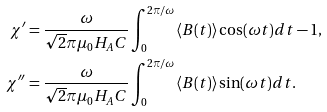Convert formula to latex. <formula><loc_0><loc_0><loc_500><loc_500>\chi ^ { \prime } & = \frac { \omega } { \sqrt { 2 } \pi \mu _ { 0 } H _ { A } C } \int ^ { 2 \pi / \omega } _ { 0 } \langle B ( t ) \rangle \cos ( \omega t ) d t - 1 , \\ \chi ^ { \prime \prime } & = \frac { \omega } { \sqrt { 2 } \pi \mu _ { 0 } H _ { A } C } \int ^ { 2 \pi / \omega } _ { 0 } \langle B ( t ) \rangle \sin ( \omega t ) d t .</formula> 